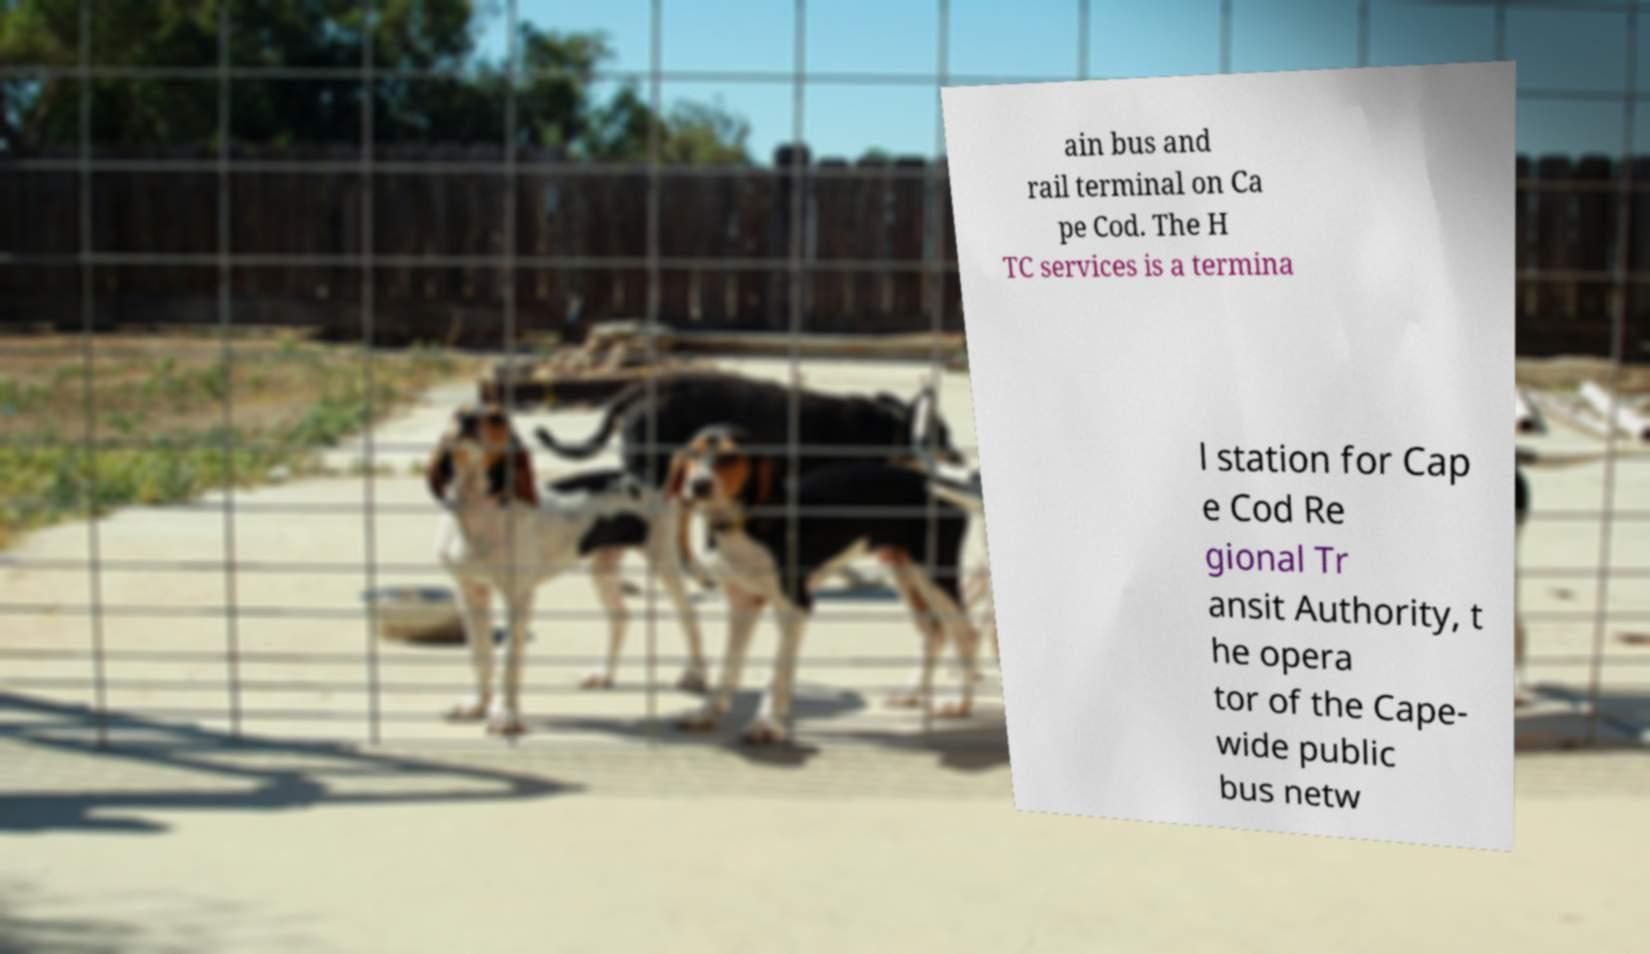What messages or text are displayed in this image? I need them in a readable, typed format. ain bus and rail terminal on Ca pe Cod. The H TC services is a termina l station for Cap e Cod Re gional Tr ansit Authority, t he opera tor of the Cape- wide public bus netw 